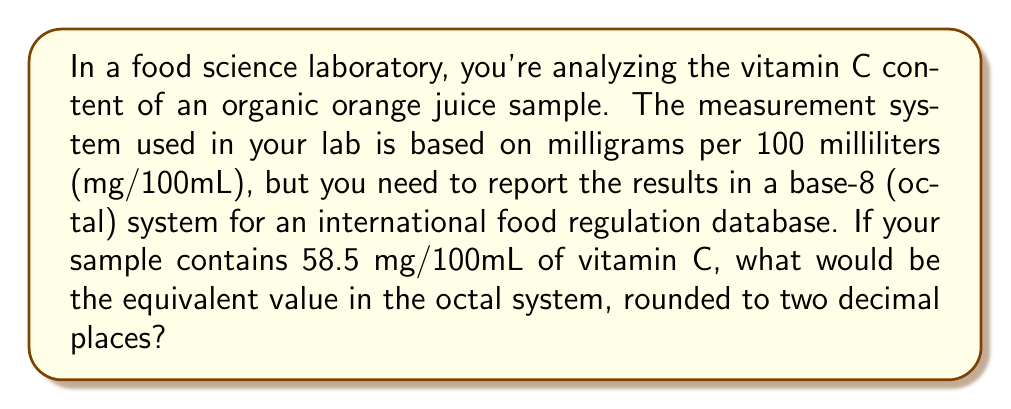Show me your answer to this math problem. To solve this problem, we need to convert the decimal number 58.5 to its octal equivalent. Here's how we can do it step-by-step:

1) First, let's separate the integer and fractional parts:
   Integer part: 58
   Fractional part: 0.5

2) Convert the integer part (58) to octal:
   $58 \div 8 = 7$ remainder $2$
   $7 \div 8 = 0$ remainder $7$
   
   Reading the remainders from bottom to top, we get: $72_8$

3) Convert the fractional part (0.5) to octal:
   $0.5 \times 8 = 4.0$
   
   The fractional part in octal is $0.4_8$

4) Combining the integer and fractional parts:
   $58.5_{10} = 72.4_8$

5) Rounding to two decimal places in octal:
   $72.4_8$ is already in two decimal places, so no further rounding is needed.

Therefore, 58.5 mg/100mL in the decimal system is equivalent to $72.4_8$ mg/100mL in the octal system.
Answer: $72.4_8$ mg/100mL 